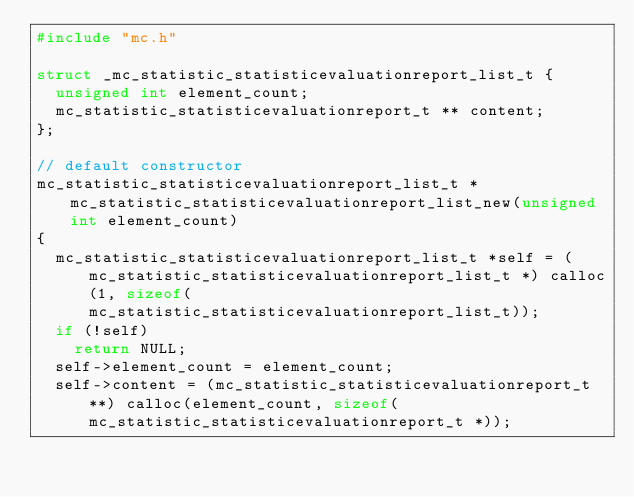Convert code to text. <code><loc_0><loc_0><loc_500><loc_500><_C_>#include "mc.h"

struct _mc_statistic_statisticevaluationreport_list_t {
  unsigned int element_count;
  mc_statistic_statisticevaluationreport_t ** content;
};

// default constructor
mc_statistic_statisticevaluationreport_list_t * mc_statistic_statisticevaluationreport_list_new(unsigned int element_count)
{
  mc_statistic_statisticevaluationreport_list_t *self = (mc_statistic_statisticevaluationreport_list_t *) calloc(1, sizeof(mc_statistic_statisticevaluationreport_list_t));
  if (!self)
    return NULL;
  self->element_count = element_count;
  self->content = (mc_statistic_statisticevaluationreport_t **) calloc(element_count, sizeof(mc_statistic_statisticevaluationreport_t *));</code> 